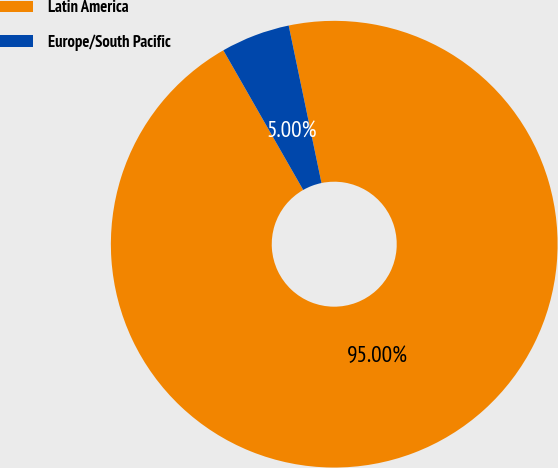Convert chart to OTSL. <chart><loc_0><loc_0><loc_500><loc_500><pie_chart><fcel>Latin America<fcel>Europe/South Pacific<nl><fcel>95.0%<fcel>5.0%<nl></chart> 